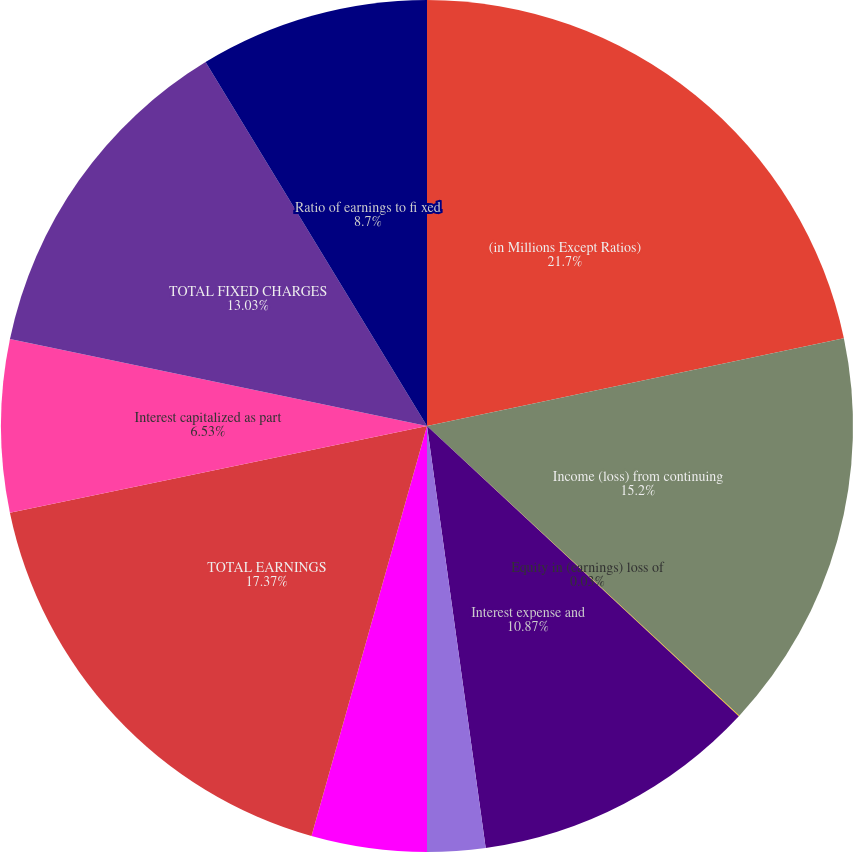<chart> <loc_0><loc_0><loc_500><loc_500><pie_chart><fcel>(in Millions Except Ratios)<fcel>Income (loss) from continuing<fcel>Equity in (earnings) loss of<fcel>Interest expense and<fcel>Amortization of capitalized<fcel>Interest included in rental<fcel>TOTAL EARNINGS<fcel>Interest capitalized as part<fcel>TOTAL FIXED CHARGES<fcel>Ratio of earnings to fi xed<nl><fcel>21.7%<fcel>15.2%<fcel>0.03%<fcel>10.87%<fcel>2.2%<fcel>4.37%<fcel>17.37%<fcel>6.53%<fcel>13.03%<fcel>8.7%<nl></chart> 